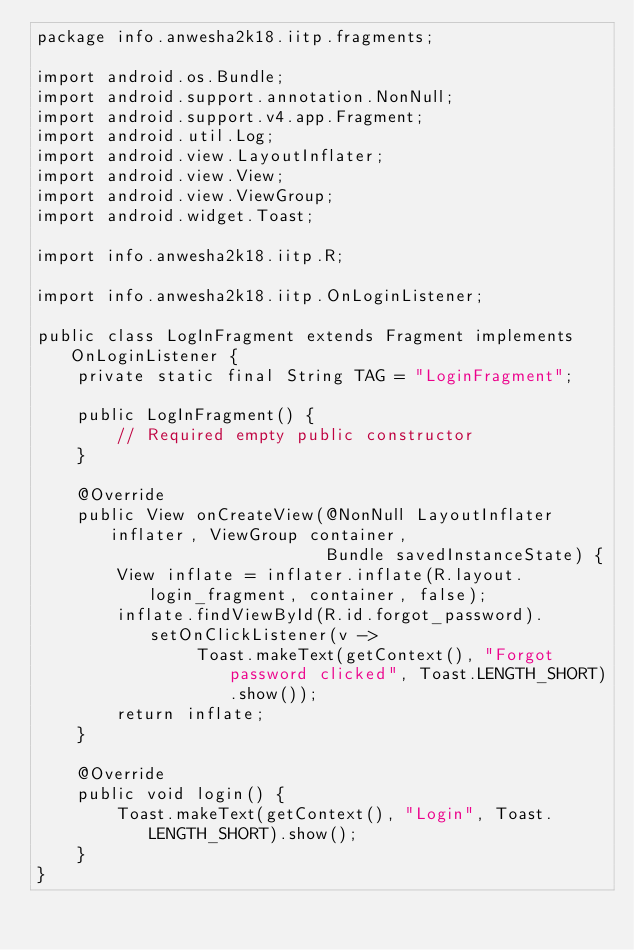<code> <loc_0><loc_0><loc_500><loc_500><_Java_>package info.anwesha2k18.iitp.fragments;

import android.os.Bundle;
import android.support.annotation.NonNull;
import android.support.v4.app.Fragment;
import android.util.Log;
import android.view.LayoutInflater;
import android.view.View;
import android.view.ViewGroup;
import android.widget.Toast;

import info.anwesha2k18.iitp.R;

import info.anwesha2k18.iitp.OnLoginListener;

public class LogInFragment extends Fragment implements OnLoginListener {
    private static final String TAG = "LoginFragment";

    public LogInFragment() {
        // Required empty public constructor
    }

    @Override
    public View onCreateView(@NonNull LayoutInflater inflater, ViewGroup container,
                             Bundle savedInstanceState) {
        View inflate = inflater.inflate(R.layout.login_fragment, container, false);
        inflate.findViewById(R.id.forgot_password).setOnClickListener(v ->
                Toast.makeText(getContext(), "Forgot password clicked", Toast.LENGTH_SHORT).show());
        return inflate;
    }

    @Override
    public void login() {
        Toast.makeText(getContext(), "Login", Toast.LENGTH_SHORT).show();
    }
}
</code> 